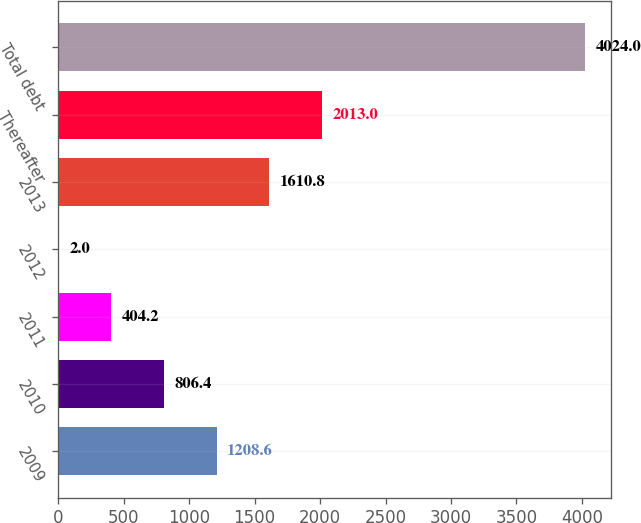<chart> <loc_0><loc_0><loc_500><loc_500><bar_chart><fcel>2009<fcel>2010<fcel>2011<fcel>2012<fcel>2013<fcel>Thereafter<fcel>Total debt<nl><fcel>1208.6<fcel>806.4<fcel>404.2<fcel>2<fcel>1610.8<fcel>2013<fcel>4024<nl></chart> 